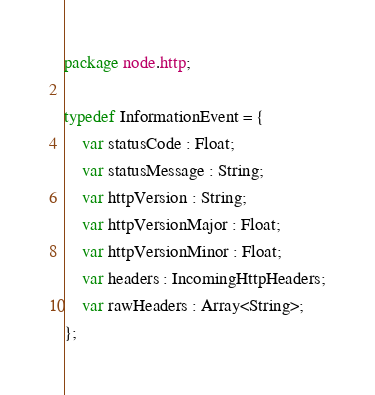<code> <loc_0><loc_0><loc_500><loc_500><_Haxe_>package node.http;

typedef InformationEvent = {
	var statusCode : Float;
	var statusMessage : String;
	var httpVersion : String;
	var httpVersionMajor : Float;
	var httpVersionMinor : Float;
	var headers : IncomingHttpHeaders;
	var rawHeaders : Array<String>;
};</code> 